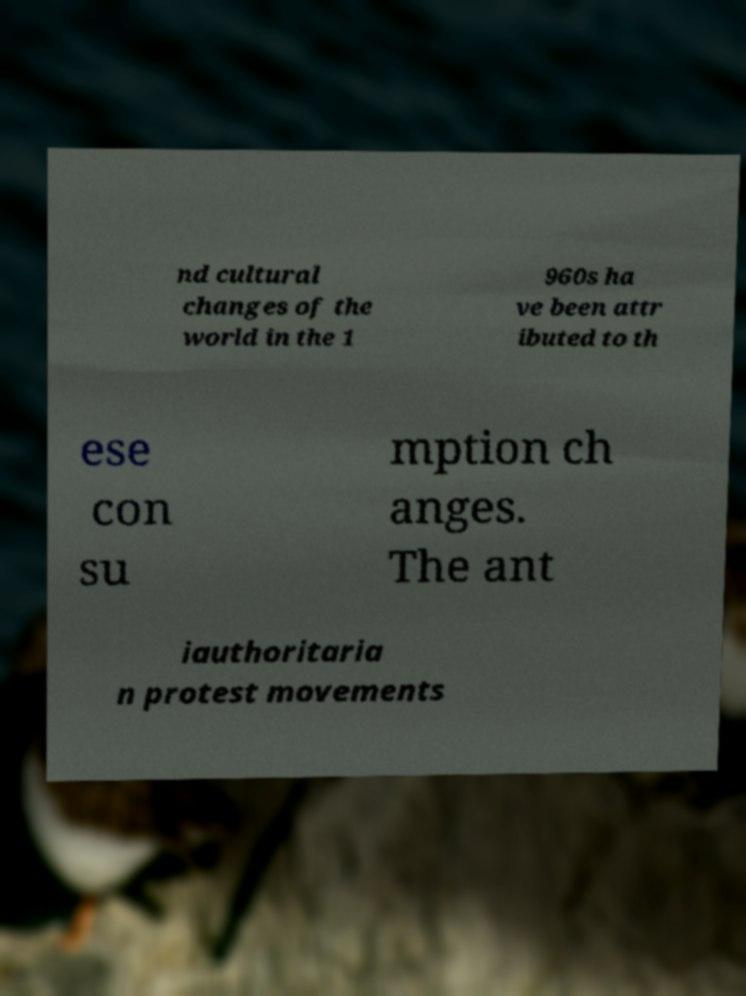Please read and relay the text visible in this image. What does it say? nd cultural changes of the world in the 1 960s ha ve been attr ibuted to th ese con su mption ch anges. The ant iauthoritaria n protest movements 